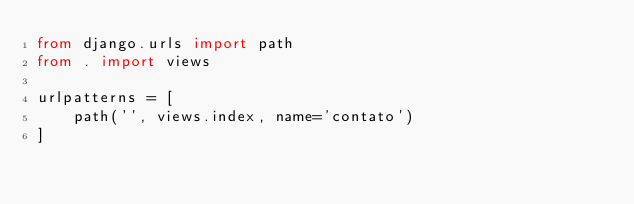<code> <loc_0><loc_0><loc_500><loc_500><_Python_>from django.urls import path
from . import views

urlpatterns = [
    path('', views.index, name='contato')
]</code> 